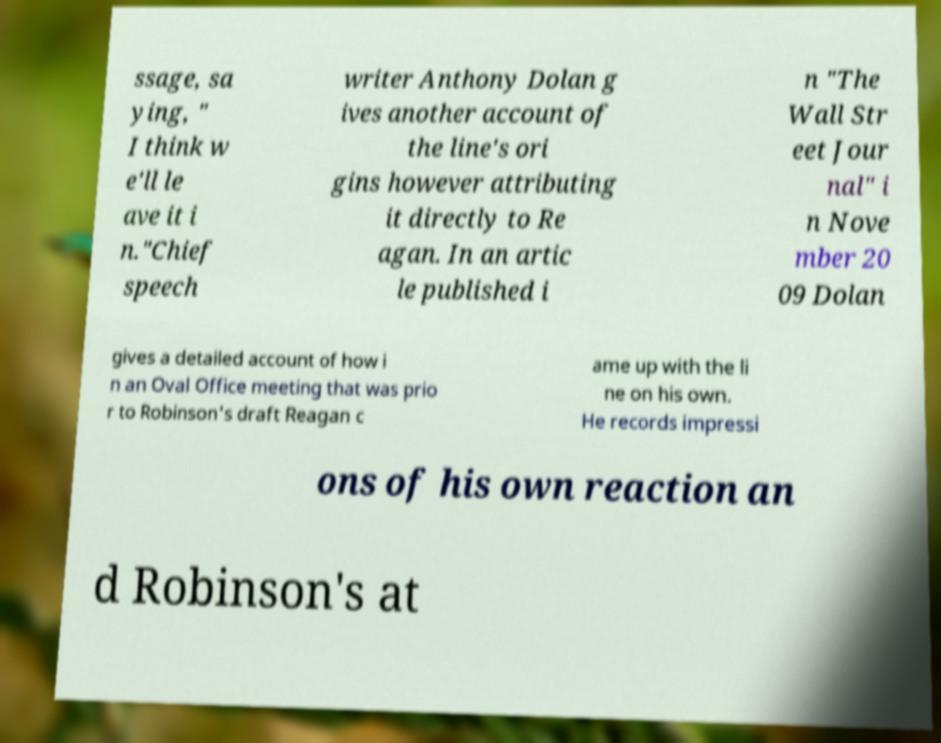Could you assist in decoding the text presented in this image and type it out clearly? ssage, sa ying, " I think w e'll le ave it i n."Chief speech writer Anthony Dolan g ives another account of the line's ori gins however attributing it directly to Re agan. In an artic le published i n "The Wall Str eet Jour nal" i n Nove mber 20 09 Dolan gives a detailed account of how i n an Oval Office meeting that was prio r to Robinson's draft Reagan c ame up with the li ne on his own. He records impressi ons of his own reaction an d Robinson's at 